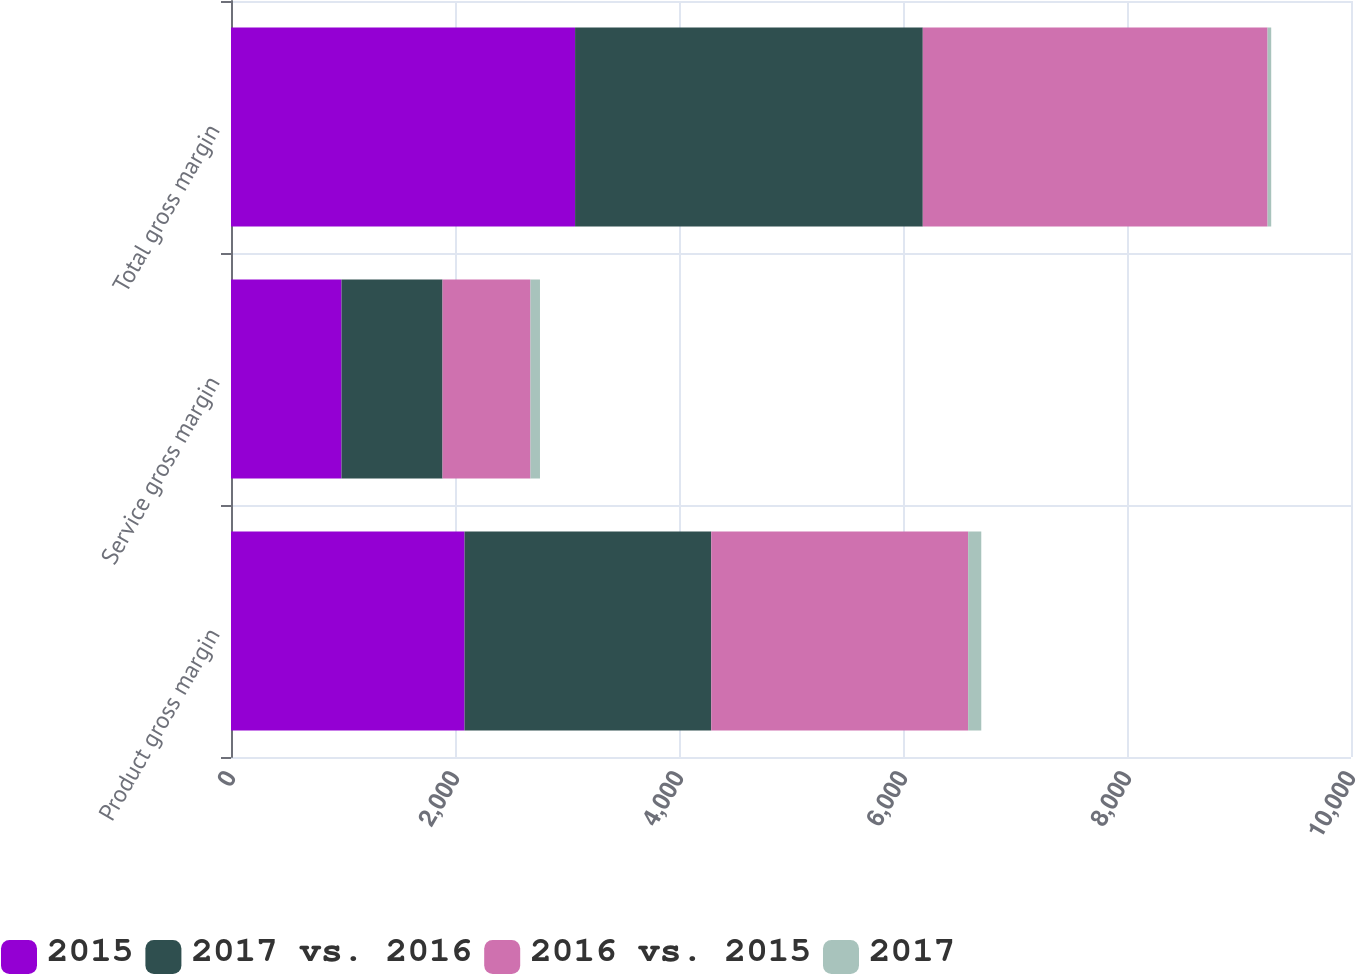Convert chart to OTSL. <chart><loc_0><loc_0><loc_500><loc_500><stacked_bar_chart><ecel><fcel>Product gross margin<fcel>Service gross margin<fcel>Total gross margin<nl><fcel>2015<fcel>2085.3<fcel>986.8<fcel>3072.1<nl><fcel>2017 vs. 2016<fcel>2202.7<fcel>901.8<fcel>3104.5<nl><fcel>2016 vs. 2015<fcel>2293.5<fcel>785.1<fcel>3078.6<nl><fcel>2017<fcel>117.4<fcel>85<fcel>32.4<nl></chart> 